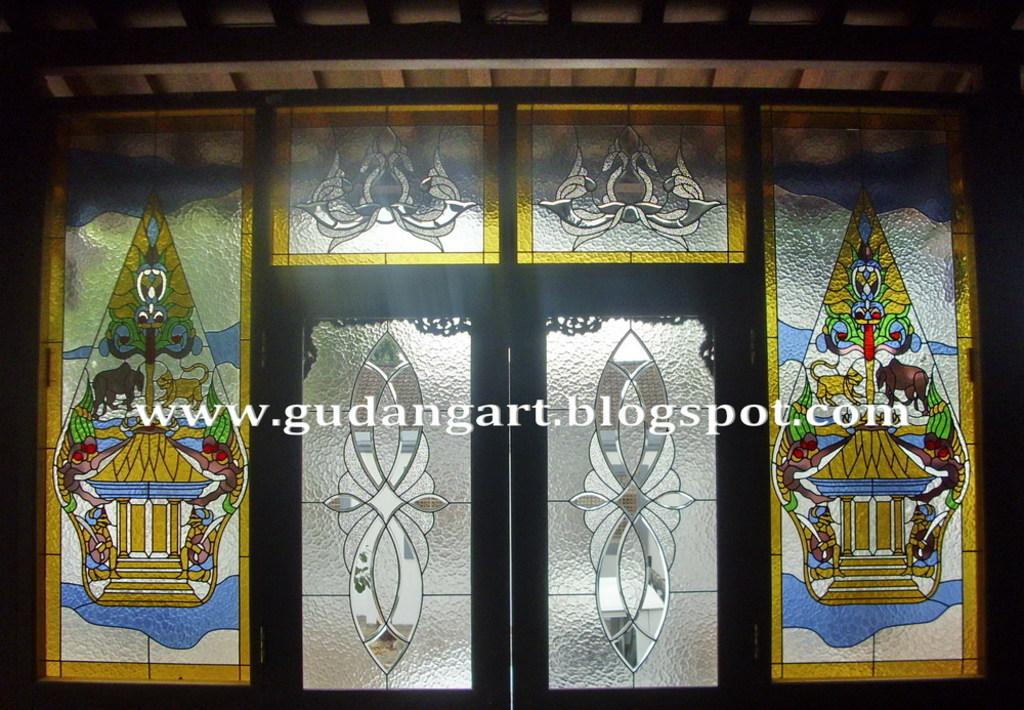What type of doors are visible in the image? There are glass doors in the image. What can be seen on the glass doors? The glass doors have designs on them. What is located at the top of the image? There is a pole at the top of the image. What is covering the area above the doors in the image? There is a roof in the image. What is written in the middle of the image? There is text written in the middle of the image. What type of rifle is visible in the image? There is no rifle present in the image. 